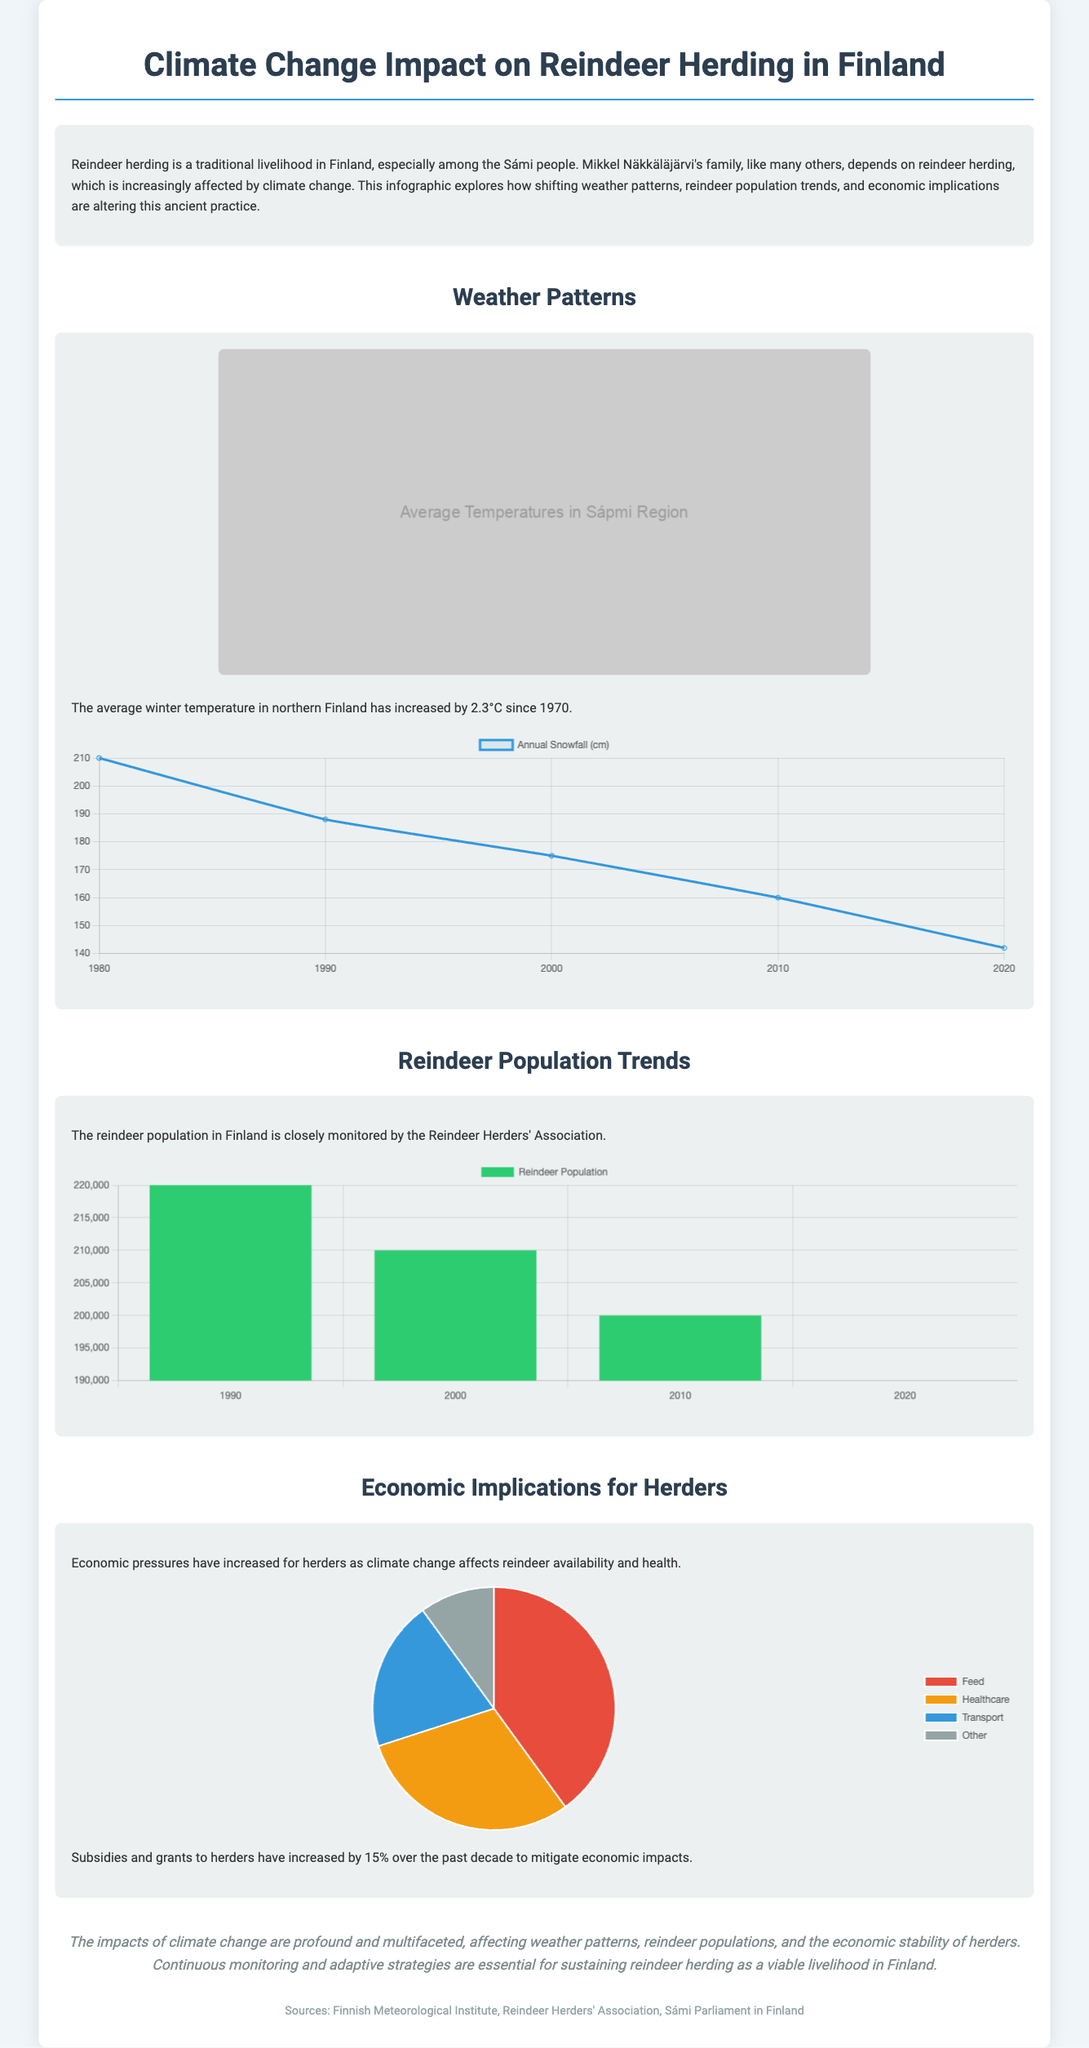What has been the increase in average winter temperature in northern Finland since 1970? The document states that the average winter temperature has increased by 2.3°C since 1970.
Answer: 2.3°C What year was the reindeer population at its highest according to the document? The highest recorded reindeer population is noted in the year 1990 with 220,000 reindeer.
Answer: 1990 What percentage increase in subsidies and grants for herders has been noted over the past decade? The document mentions a 15% increase in subsidies and grants to herders in the past decade.
Answer: 15% What was the annual snowfall in centimeters recorded in 2020? Based on the snowfall chart, the annual snowfall recorded in 2020 was 142 cm.
Answer: 142 cm What are the top three expenses for herders as indicated in the cost distribution chart? The cost distribution chart reveals the top three expenses for herders are Feed, Healthcare, and Transport.
Answer: Feed, Healthcare, Transport What significant trend can be observed in the reindeer population from 1990 to 2020? The reindeer population has declined from 220,000 in 1990 to 190,000 in 2020, indicating a downward trend.
Answer: Downward trend What type of chart is used for displaying the reindeer population trends? The reindeer population trends are displayed using a bar chart according to the document's description.
Answer: Bar chart What has been the state of annual snowfall from the 1980s to 2020 based on observed data? The document indicates that annual snowfall has decreased from 210 cm in 1980 to 142 cm in 2020.
Answer: Decreased 